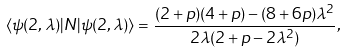Convert formula to latex. <formula><loc_0><loc_0><loc_500><loc_500>\langle \psi ( 2 , \lambda ) | N | \psi ( 2 , \lambda ) \rangle = \frac { ( 2 + p ) ( 4 + p ) - ( 8 + 6 p ) \lambda ^ { 2 } } { 2 \lambda ( 2 + p - 2 \lambda ^ { 2 } ) } ,</formula> 